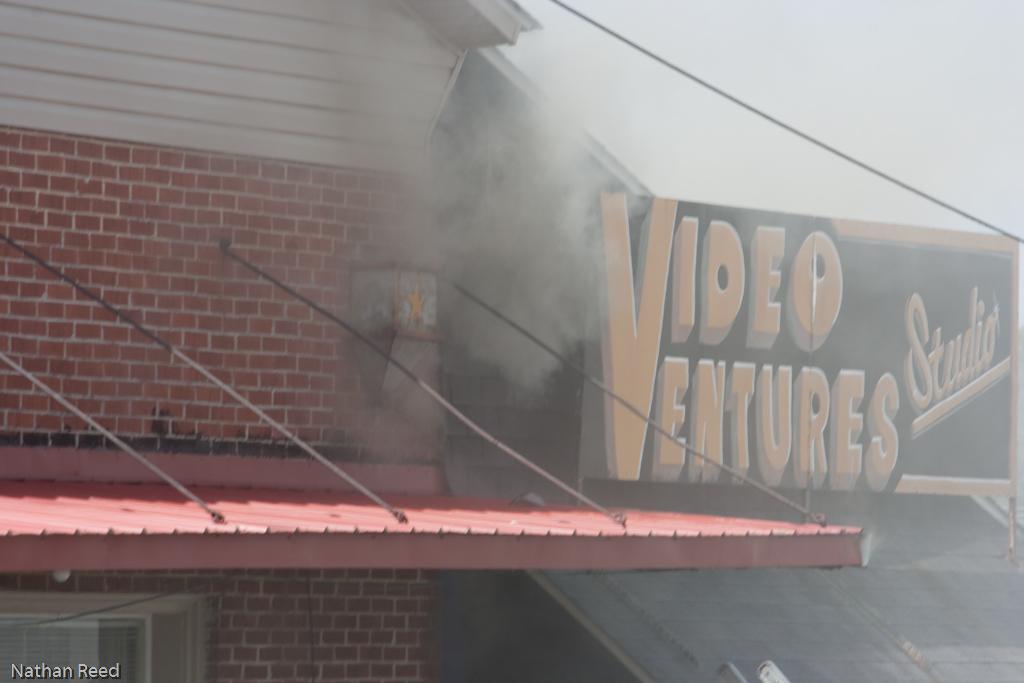Describe this image in one or two sentences. In this image I can see few buildings, some smoke and a board which is yellow and black in color. In the background I can see the sky. 